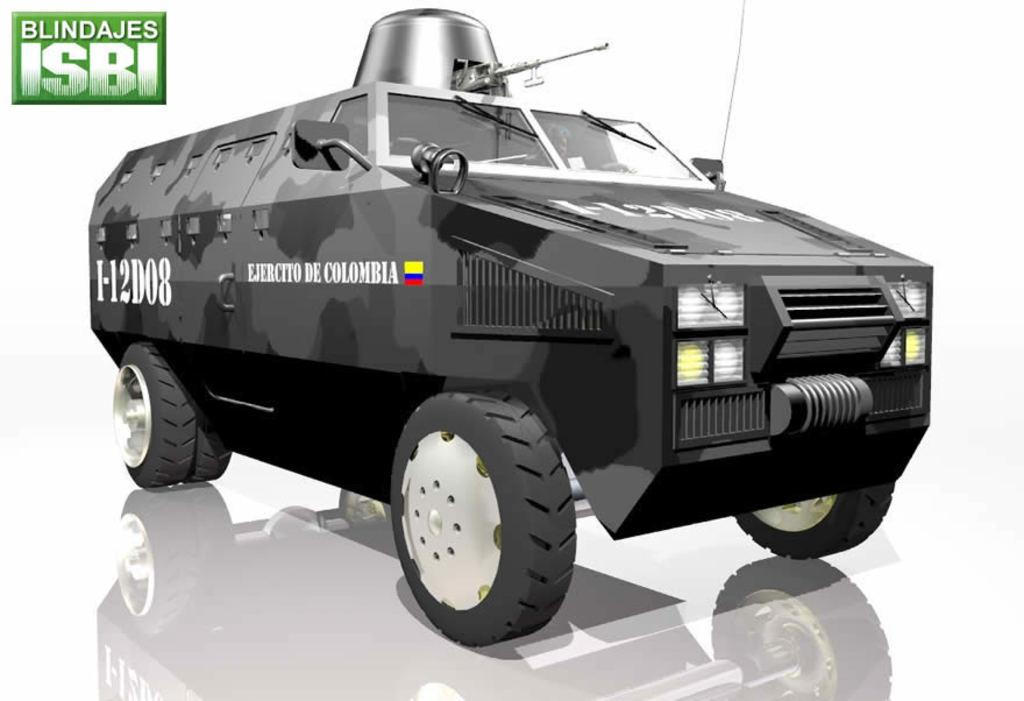What is the color of the car in the image? The car is black in color. What time of day is depicted in the image, and how many letters are visible on the car? The time of day is not mentioned in the facts, and there is no information about letters on the car. Therefore, we cannot answer these questions based on the provided information. 